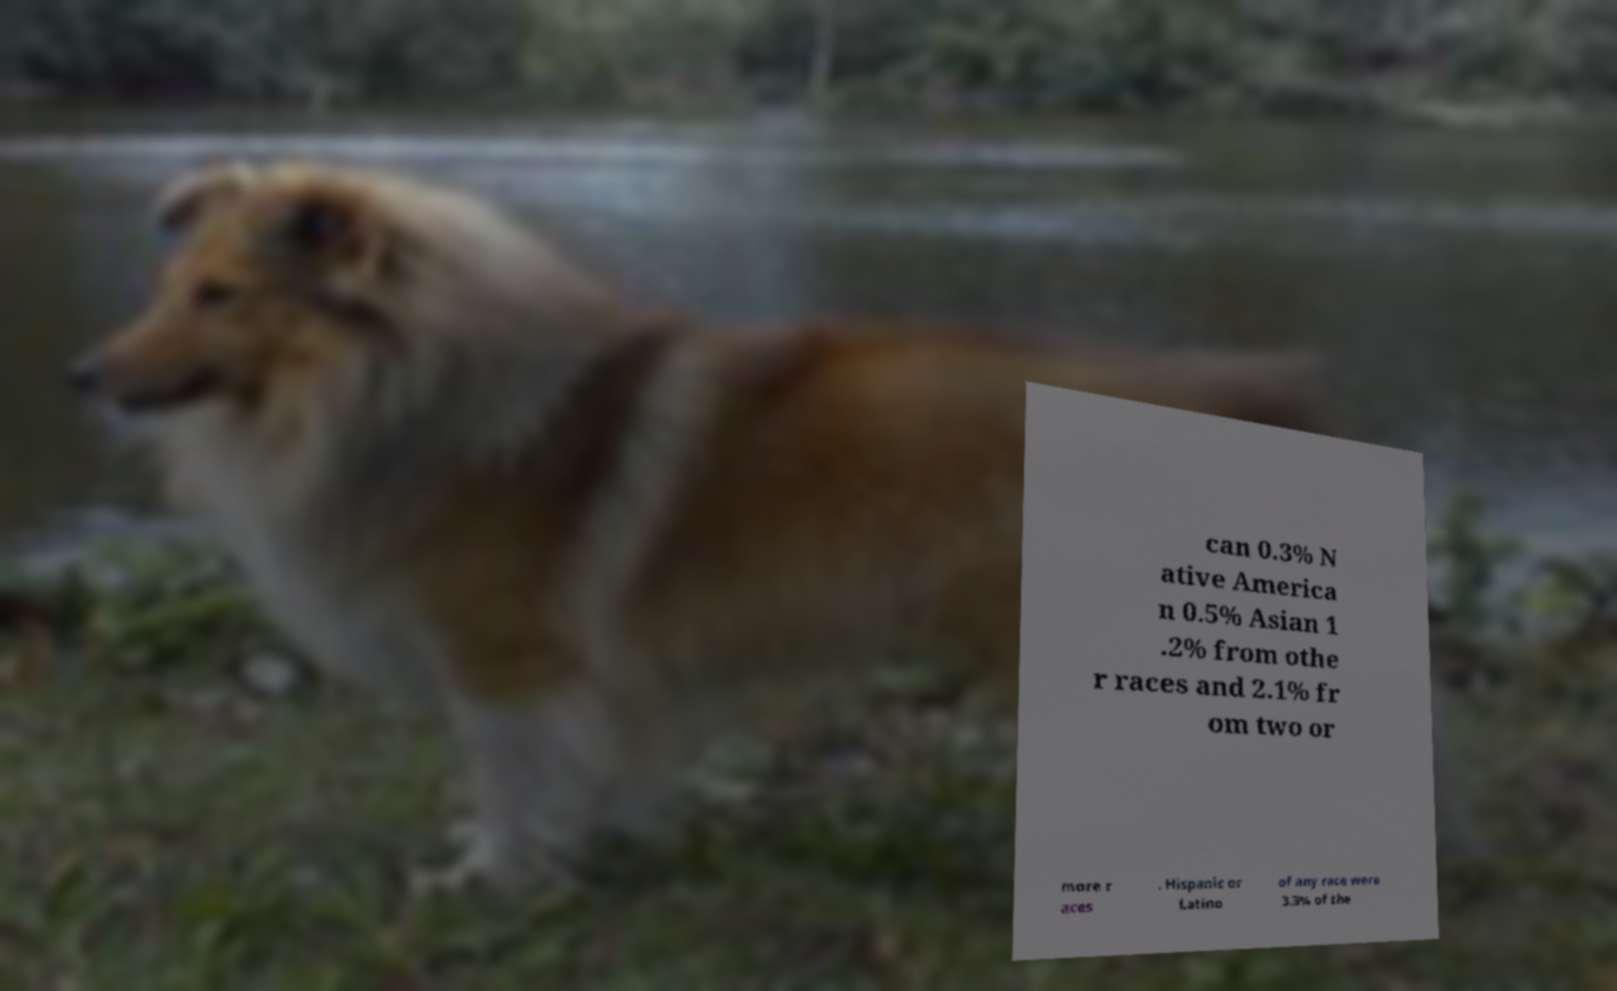Could you assist in decoding the text presented in this image and type it out clearly? can 0.3% N ative America n 0.5% Asian 1 .2% from othe r races and 2.1% fr om two or more r aces . Hispanic or Latino of any race were 3.3% of the 